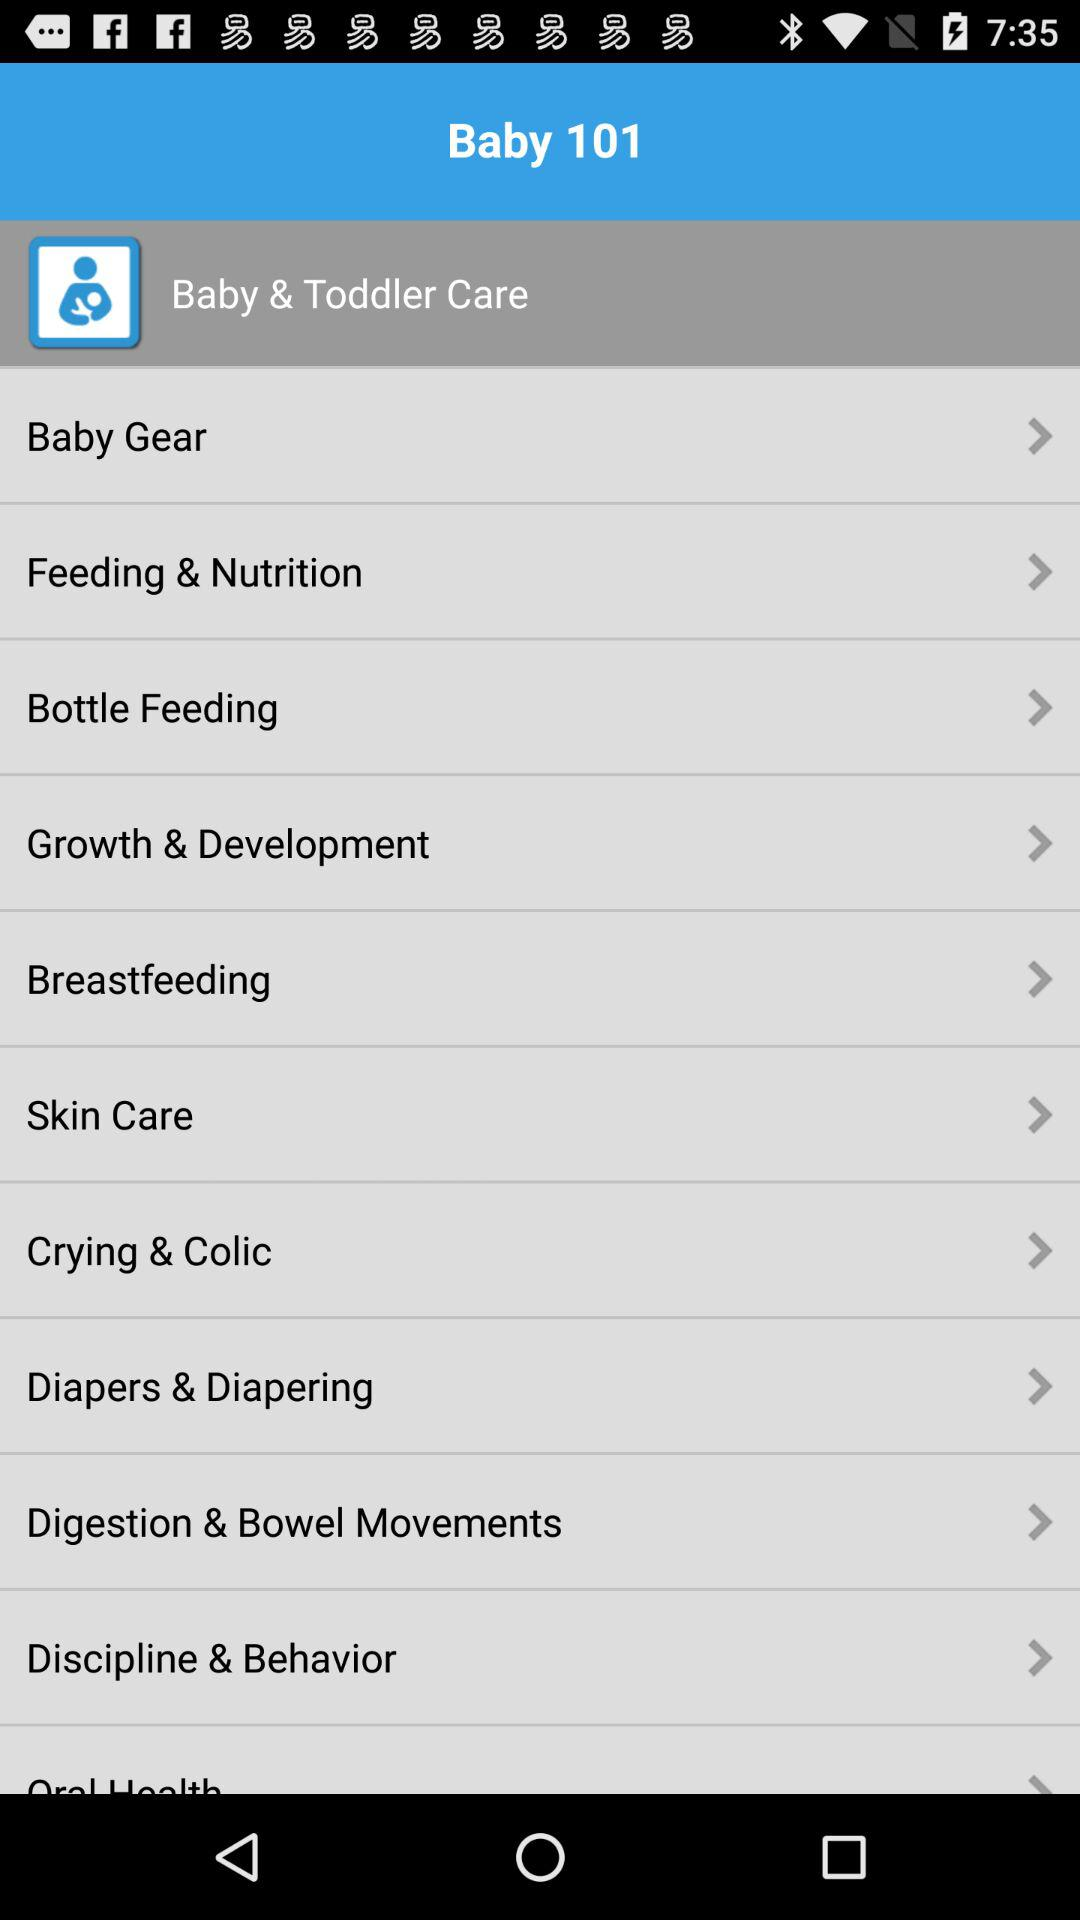What is the app name? The app name is "Baby 101". 